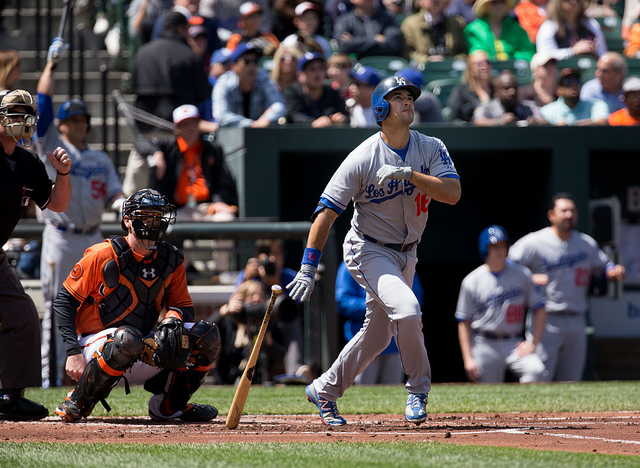Please transcribe the text information in this image. Los 16 8 